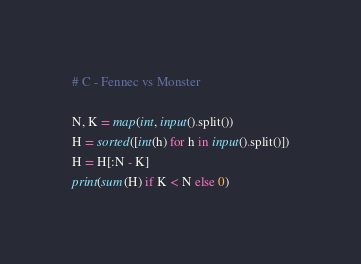Convert code to text. <code><loc_0><loc_0><loc_500><loc_500><_Python_># C - Fennec vs Monster

N, K = map(int, input().split())
H = sorted([int(h) for h in input().split()])
H = H[:N - K]
print(sum(H) if K < N else 0)
</code> 